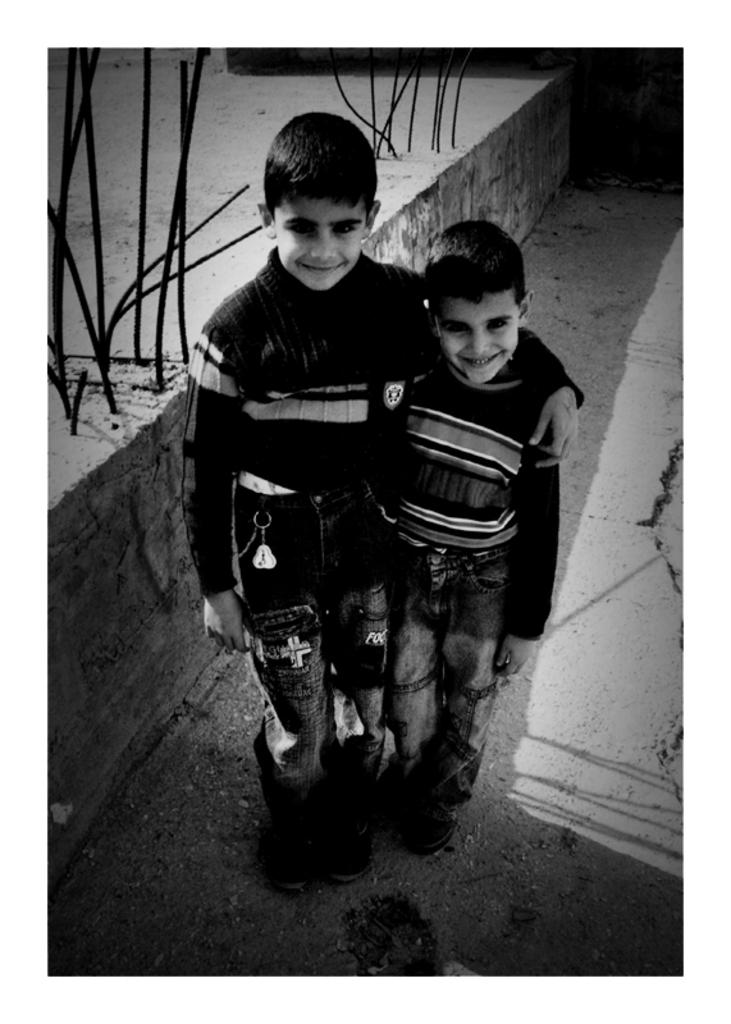How many children are present in the image? There are two children in the image. What are the children doing in the image? The children are sending something. Can you describe the children's expressions in the image? There is a smile on the children's faces. What is the color scheme of the image? The image is black and white in color. What invention is the mom using to communicate with the children in the image? There is no mom present in the image, and therefore no invention can be observed. 